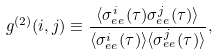Convert formula to latex. <formula><loc_0><loc_0><loc_500><loc_500>g ^ { ( 2 ) } ( i , j ) & \equiv \frac { \langle \sigma _ { e e } ^ { i } ( \tau ) \sigma _ { e e } ^ { j } ( \tau ) \rangle } { \langle \sigma _ { e e } ^ { i } ( \tau ) \rangle \langle \sigma _ { e e } ^ { j } ( \tau ) \rangle } ,</formula> 